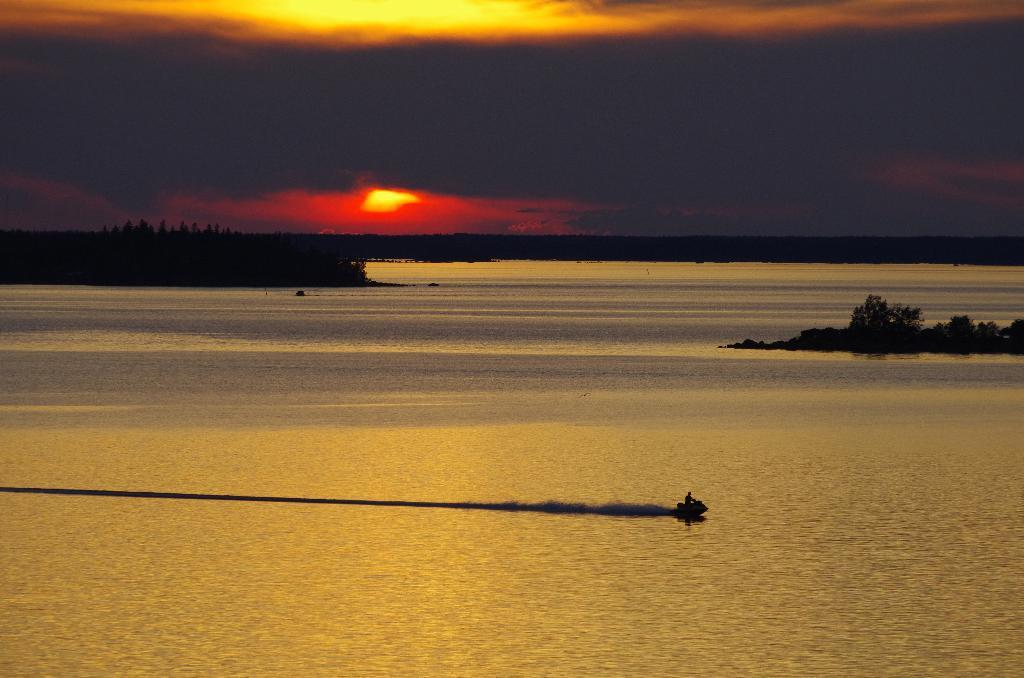What is in the water in the image? There are boats in the water in the image. What can be seen in the background of the image? There are trees and the sky visible in the background. Is the sun visible in the image? Yes, the sun is visible in the background. What type of health issue is affecting the boats in the image? There is no indication of any health issues affecting the boats in the image. Can you see any boats burning in the image? There is no indication of any boats on fire or burning in the image. 